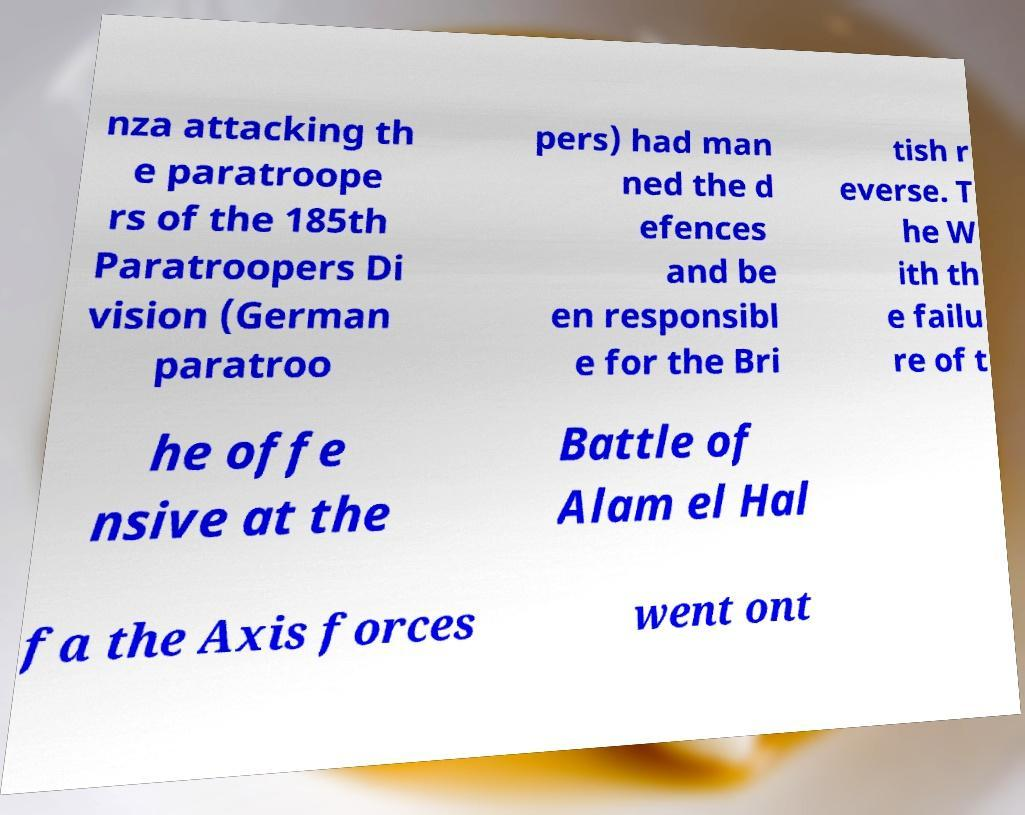Please read and relay the text visible in this image. What does it say? nza attacking th e paratroope rs of the 185th Paratroopers Di vision (German paratroo pers) had man ned the d efences and be en responsibl e for the Bri tish r everse. T he W ith th e failu re of t he offe nsive at the Battle of Alam el Hal fa the Axis forces went ont 